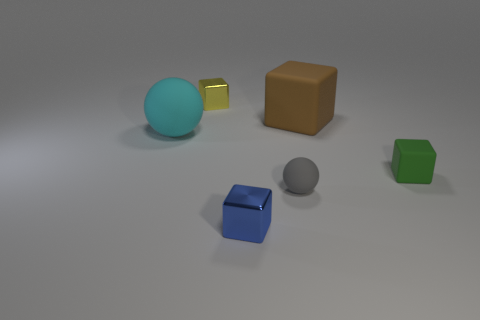The cyan object that is made of the same material as the gray thing is what shape?
Offer a terse response. Sphere. The small thing behind the large matte thing on the right side of the large matte thing that is in front of the large brown block is made of what material?
Give a very brief answer. Metal. What number of objects are green things that are to the right of the brown rubber thing or small gray matte spheres?
Make the answer very short. 2. What number of other objects are the same shape as the tiny green rubber thing?
Your answer should be compact. 3. Are there more rubber spheres in front of the cyan rubber ball than small brown spheres?
Your response must be concise. Yes. What is the size of the brown object that is the same shape as the tiny yellow shiny thing?
Keep it short and to the point. Large. Is there any other thing that has the same material as the tiny green block?
Offer a very short reply. Yes. The blue thing has what shape?
Offer a very short reply. Cube. There is a cyan matte thing that is the same size as the brown matte block; what shape is it?
Ensure brevity in your answer.  Sphere. There is a brown object that is made of the same material as the cyan sphere; what size is it?
Give a very brief answer. Large. 